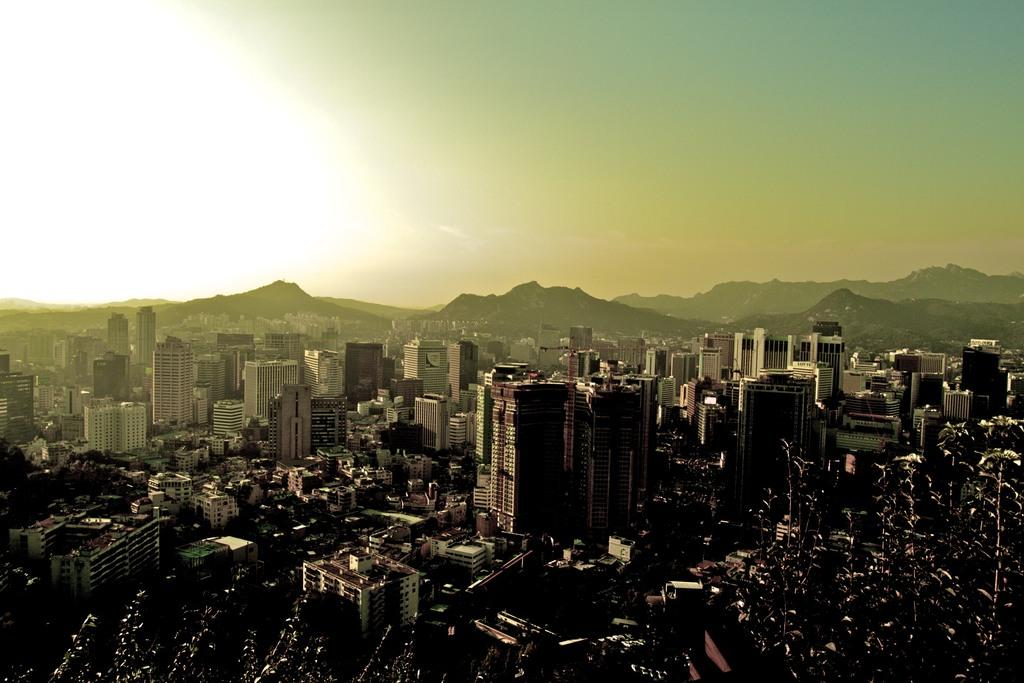What type of view is depicted in the image? The image is an aerial view. What type of natural vegetation can be seen in the image? There are trees in the image. What type of man-made structures are visible in the image? There are buildings and houses in the image. What type of geographical feature can be seen in the image? There are mountains in the image. What is visible in the sky in the image? The sky is visible in the image. What type of balls can be seen in the image? There are no balls visible in the image. What event is taking place in the image? There is no event depicted in the image; it is a still aerial view of the landscape. 